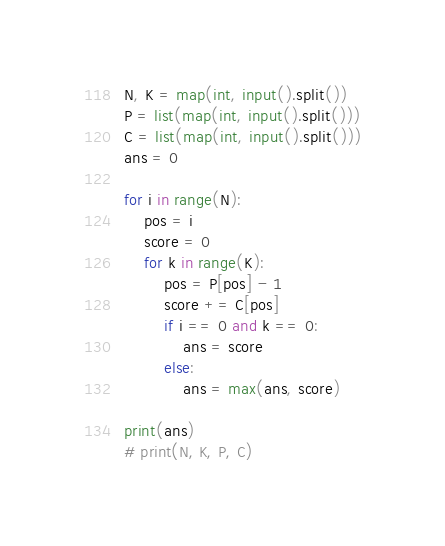Convert code to text. <code><loc_0><loc_0><loc_500><loc_500><_Python_>N, K = map(int, input().split())
P = list(map(int, input().split()))
C = list(map(int, input().split()))
ans = 0

for i in range(N):
    pos = i
    score = 0
    for k in range(K):
        pos = P[pos] - 1
        score += C[pos]
        if i == 0 and k == 0:
            ans = score
        else:
            ans = max(ans, score)

print(ans)
# print(N, K, P, C)
</code> 